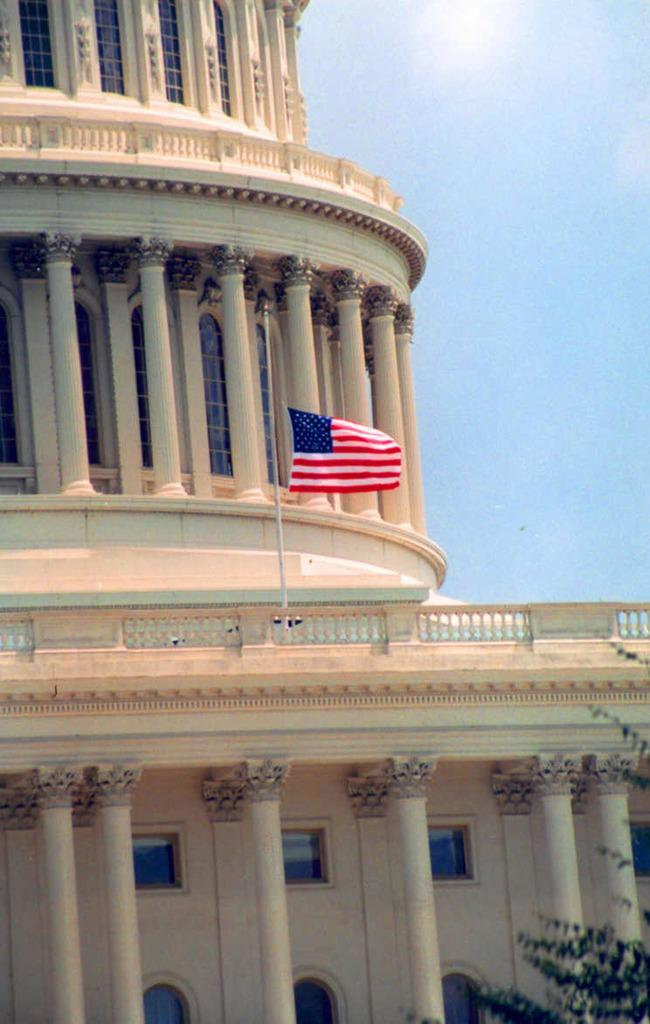What type of structure is visible in the image? There is a building in the image. What can be seen flying near the building? There is an American flag in the image. Where is the magic alley located in the image? There is no mention of a magic alley in the image; it only features a building and an American flag. 